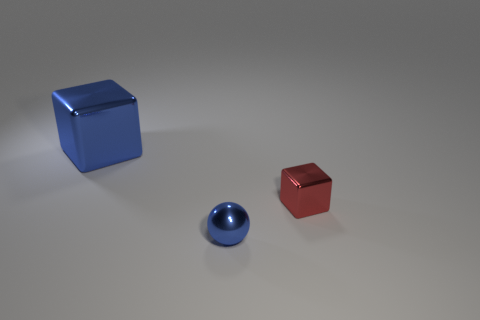What material is the block that is to the right of the cube behind the small cube?
Offer a very short reply. Metal. There is a object that is in front of the red shiny object; what is its size?
Your answer should be compact. Small. What number of blue objects are spheres or tiny cubes?
Your answer should be very brief. 1. Is there anything else that has the same material as the big thing?
Your answer should be very brief. Yes. There is another object that is the same shape as the big blue shiny thing; what material is it?
Your response must be concise. Metal. Are there the same number of tiny red things that are in front of the tiny metallic cube and blue metallic objects?
Your response must be concise. No. There is a metallic thing that is to the left of the red metallic cube and behind the tiny metallic sphere; what size is it?
Offer a terse response. Large. Is there any other thing of the same color as the large metallic object?
Make the answer very short. Yes. There is a block that is right of the blue metal object in front of the big blue object; what is its size?
Offer a very short reply. Small. What color is the object that is both on the right side of the large blue block and behind the tiny blue metal thing?
Your response must be concise. Red. 